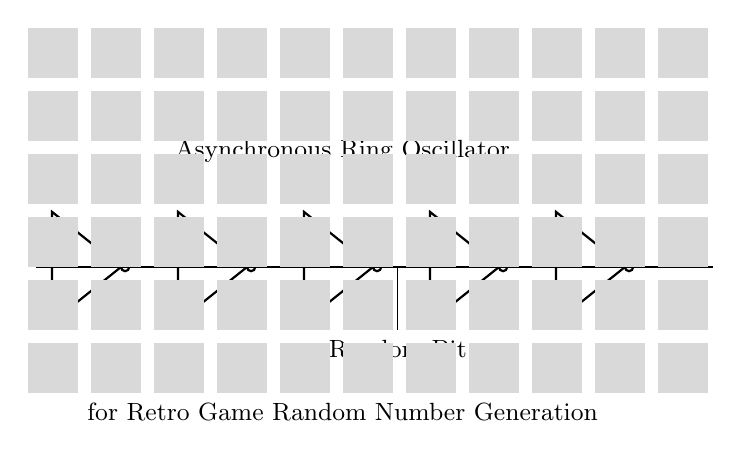What type of components are used in this circuit? The circuit consists of five inverters connected in a loop, which are the primary components used to create the ring oscillator.
Answer: Inverters How many inverters are present in the circuit? There are five inverters, as indicated by the five not ports in the diagram.
Answer: Five What is the output of the asynchronous ring oscillator? The output is a random bit, which is generated from the oscillating signal produced by the inverters.
Answer: Random Bit What does the circuit generate for retro games? This circuit is designed for generating random numbers, which is essential for various functionalities in retro games, such as random encounters or item drops.
Answer: Random Numbers Why is it called an "asynchronous" ring oscillator? It is termed "asynchronous" because the inverters do not rely on a clock signal; instead, they produce oscillations based on the feedback loop created in the circuit.
Answer: No clock signal What is the purpose of the feedback loop in this circuit? The feedback loop allows the output of the last inverter to connect back to the first inverter, creating a continual oscillation and enabling the generation of random bits.
Answer: Continual oscillation What could happen if one inverter is removed from the circuit? Removing an inverter disrupts the loop, preventing the circuit from oscillating and thus stopping the generation of random bits.
Answer: Stops generation 